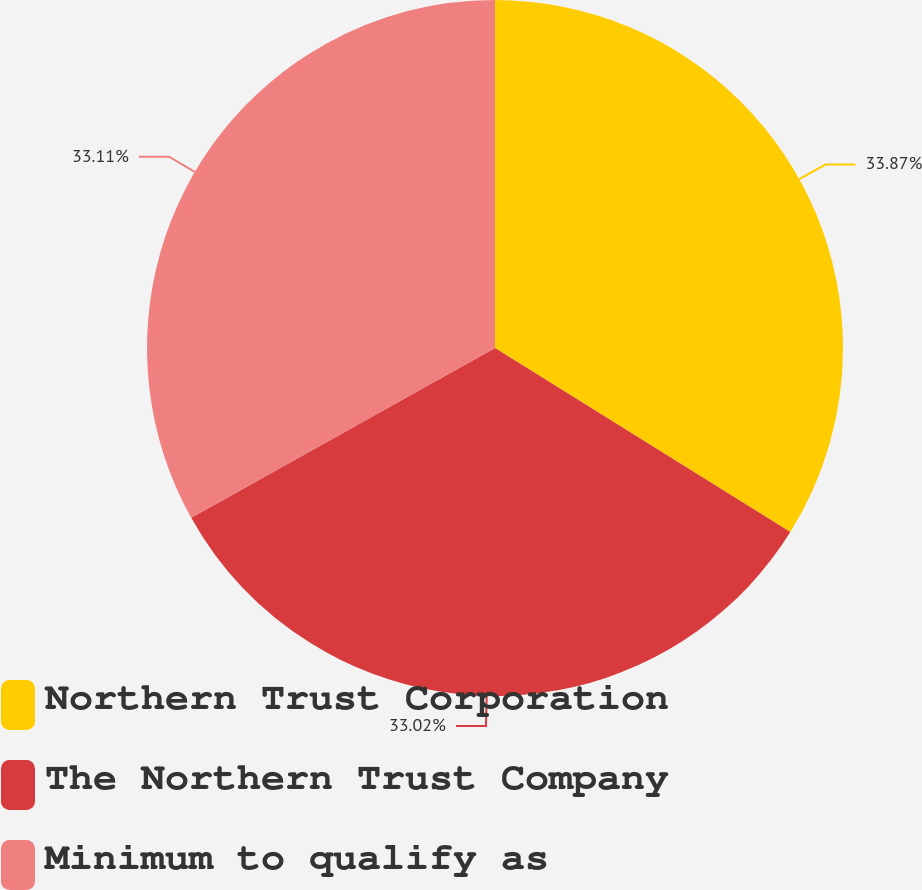Convert chart. <chart><loc_0><loc_0><loc_500><loc_500><pie_chart><fcel>Northern Trust Corporation<fcel>The Northern Trust Company<fcel>Minimum to qualify as<nl><fcel>33.87%<fcel>33.02%<fcel>33.11%<nl></chart> 